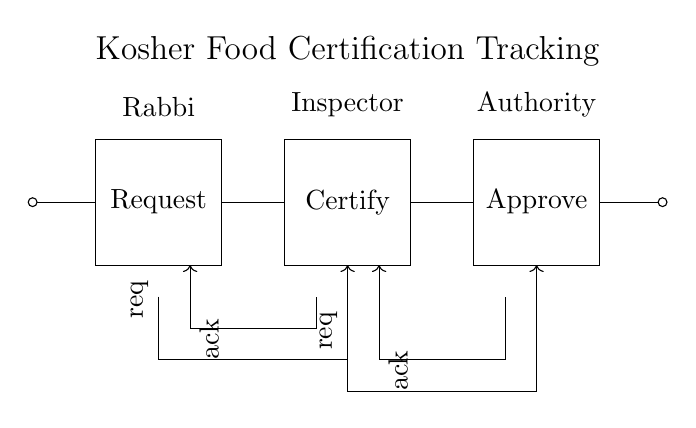What is the first component in the circuit? The first component is a circular input node, which signifies the start of the handshake protocol. It indicates the initiation point for requests in the certification process.
Answer: Circular input node What is the role of the Rabbi in the circuit? The Rabbi is the first rectangle labeled "Request". This implies he initiates the request for kosher certification.
Answer: Request What signifies the approval phase in the circuit? The third rectangle labeled "Approve" represents the approval phase in the certification process, which is crucial after the inspection.
Answer: Approve How many main components are there in the circuit? There are three main components: Request, Certify, and Approve. Each of these components corresponds to a key step in the certification process.
Answer: Three What type of communication is depicted in the diagram? The diagram depicts asynchronous communication through the handshake protocol, where acknowledgments are sent back and forth between the Rabbi, Inspector, and Authority.
Answer: Asynchronous What does the arrow going from Certify to Approve represent? The arrow indicates a request being made from the Certify phase to the Approve phase, demonstrating the flow of information after the certification process is completed.
Answer: Request flow 